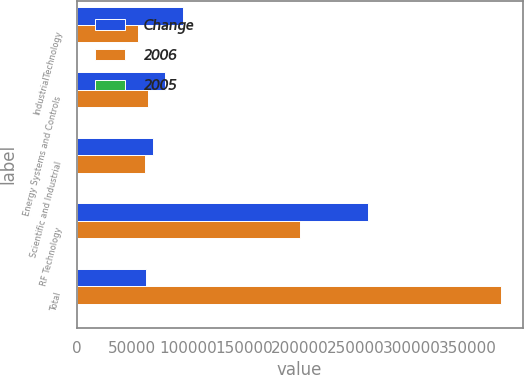Convert chart to OTSL. <chart><loc_0><loc_0><loc_500><loc_500><stacked_bar_chart><ecel><fcel>IndustrialTechnology<fcel>Energy Systems and Controls<fcel>Scientific and Industrial<fcel>RF Technology<fcel>Total<nl><fcel>Change<fcel>95539<fcel>79217<fcel>68600<fcel>261243<fcel>62594.5<nl><fcel>2006<fcel>54959<fcel>63583<fcel>61606<fcel>200233<fcel>380381<nl><fcel>2005<fcel>73.8<fcel>24.6<fcel>11.4<fcel>30.5<fcel>32.7<nl></chart> 